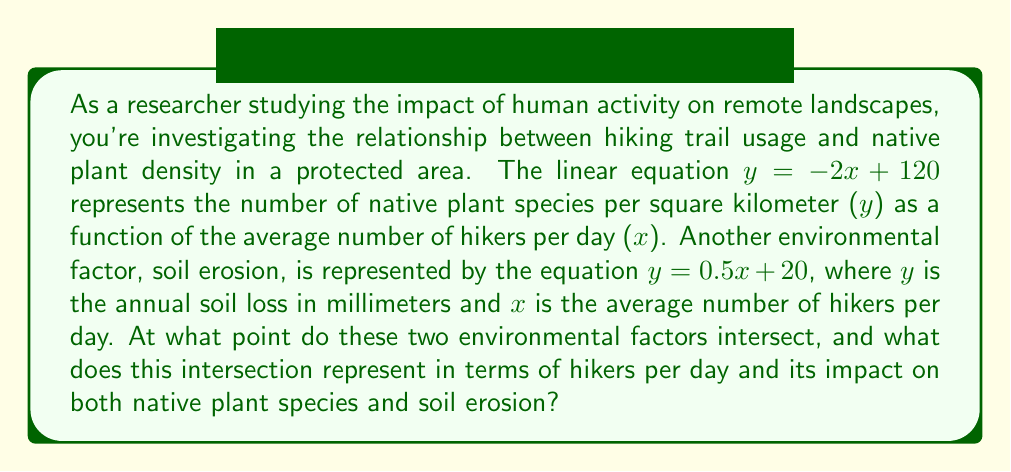Can you answer this question? To find the intersection point of these two linear equations, we need to solve them simultaneously. Let's approach this step-by-step:

1) We have two equations:
   
   Equation 1 (native plant species): $y = -2x + 120$
   Equation 2 (soil erosion): $y = 0.5x + 20$

2) At the intersection point, the $y$ values will be equal. So we can set the right sides of these equations equal to each other:

   $$-2x + 120 = 0.5x + 20$$

3) Now, let's solve this equation for $x$:
   
   $$-2x + 120 = 0.5x + 20$$
   $$-2.5x + 120 = 20$$
   $$-2.5x = -100$$
   $$x = 40$$

4) Now that we know the $x$ coordinate of the intersection point, we can find the $y$ coordinate by plugging $x = 40$ into either of our original equations. Let's use the first equation:

   $$y = -2(40) + 120 = -80 + 120 = 40$$

5) Therefore, the intersection point is $(40, 40)$.

This point represents:
- An average of 40 hikers per day
- 40 native plant species per square kilometer
- 40 mm of annual soil loss
Answer: The intersection point is $(40, 40)$, representing 40 hikers per day, 40 native plant species per square kilometer, and 40 mm of annual soil loss. 